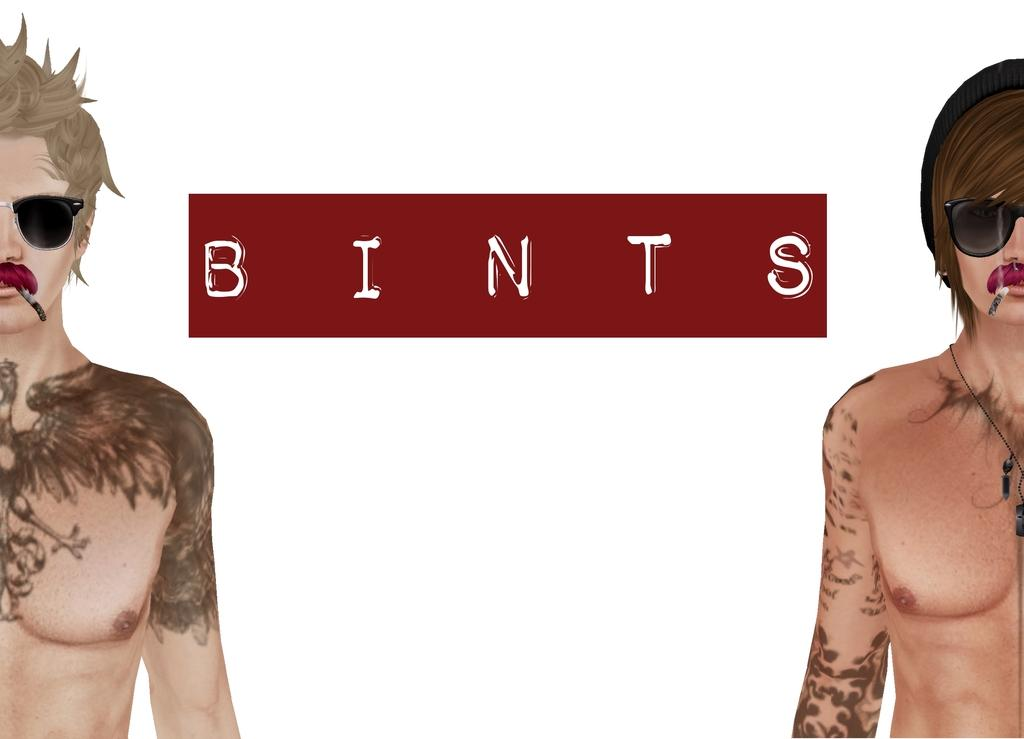What is the main subject of the image? There is an animation in the image. How many people are present in the image? There are two persons, one on the right side and one on the left side. What is located in the center of the image? There is text in the center of the image. What color is the background of the image? The background of the image is white. Can you tell me how deep the river is in the image? There is no river present in the image; it features an animation with two persons and text on a white background. What type of health issue is being discussed in the image? There is no health issue being discussed in the image; it features an animation with two persons and text on a white background. 